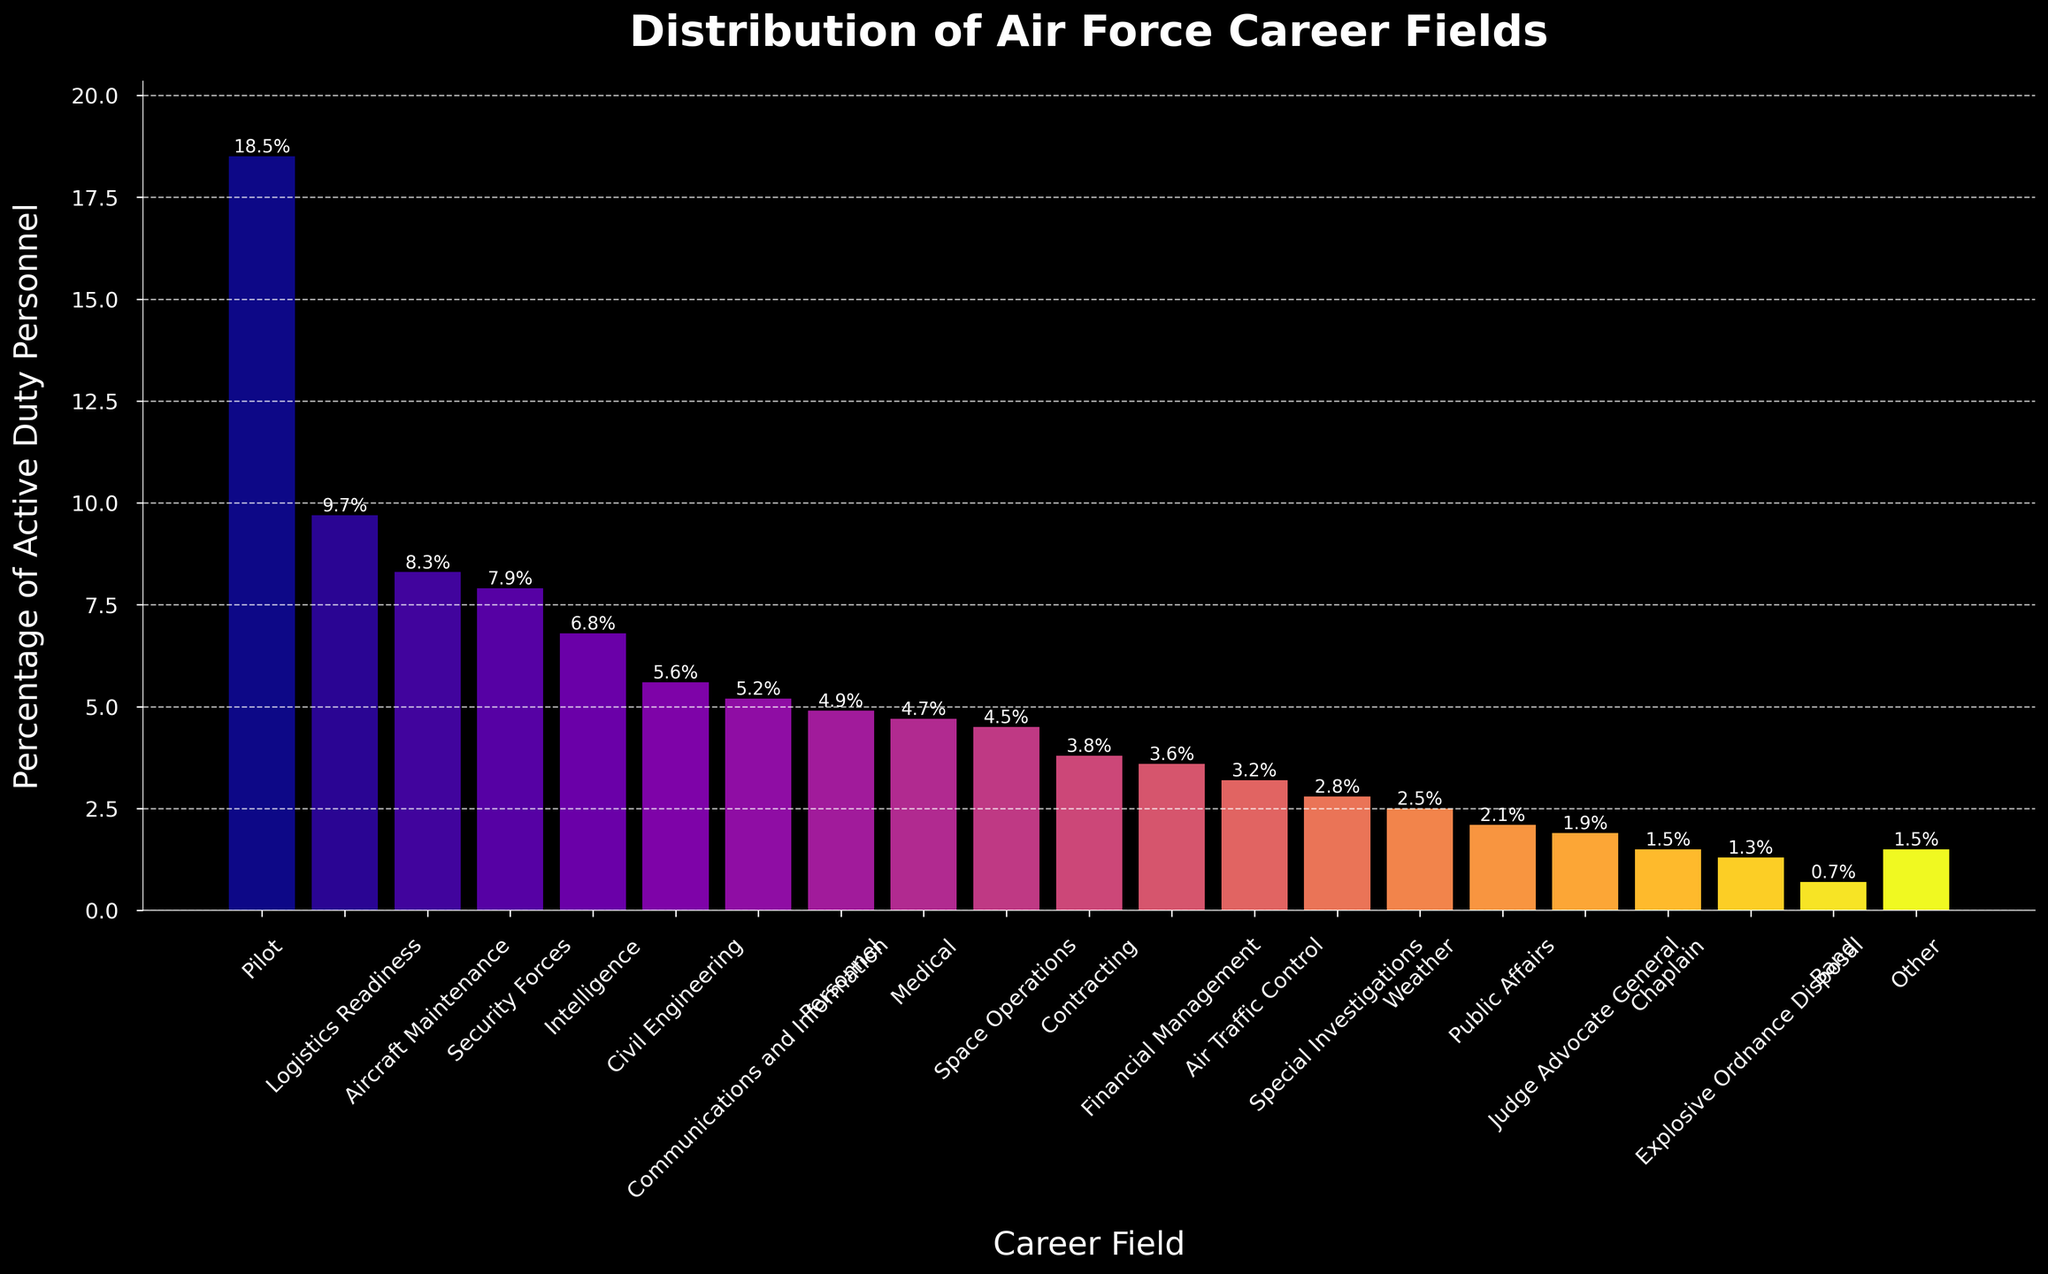What is the percentage of active duty personnel in the Pilot career field? The bar representing the Pilot career field shows a value of 18.5%.
Answer: 18.5% Which career field has a higher percentage, Security Forces or Intelligence? The bar for Security Forces shows 7.9%, while the bar for Intelligence shows 6.8%. Therefore, Security Forces has a higher percentage.
Answer: Security Forces What are the three career fields with the lowest percentages? The bars representing Band (0.7%), Explosive Ordnance Disposal (1.3%), and Chaplain (1.5%) show the lowest percentages.
Answer: Band, Explosive Ordnance Disposal, Chaplain How much greater is the percentage of active duty personnel in Logistics Readiness compared to Civil Engineering? Logistics Readiness is at 9.7% and Civil Engineering is at 5.6%. The difference is 9.7% - 5.6% = 4.1%.
Answer: 4.1% Which career field has the median percentage value, and what is this value? First, list the percentages in ascending order, then find the middle value(s): [0.7, 1.3, 1.5, 1.5, 1.9, 2.1, 2.5, 2.8, 3.2, 3.6, 3.8, 4.5, 4.7, 4.9, 5.2, 5.6, 6.8, 7.9, 8.3, 9.7, 18.5]. The median value is the 11th value, which is 3.8% (Contracting).
Answer: Contracting, 3.8% What is the total percentage of active duty personnel in the top five career fields? Summing the percentages of the top five career fields: Pilot (18.5%) + Logistics Readiness (9.7%) + Aircraft Maintenance (8.3%) + Security Forces (7.9%) + Intelligence (6.8%) = 51.2%.
Answer: 51.2% Compare the percentages of Air Traffic Control and Explosive Ordnance Disposal. Which one is higher, and by how much? The Air Traffic Control field shows 3.2%, and Explosive Ordnance Disposal shows 1.3%. The difference is 3.2% - 1.3% = 1.9%. Air Traffic Control is higher by 1.9%.
Answer: Air Traffic Control, 1.9% What is the combined percentage of Contracting and Financial Management? Adding the percentages of Contracting (3.8%) and Financial Management (3.6%): 3.8% + 3.6% = 7.4%.
Answer: 7.4% How much lower is the percentage of active duty personnel in the Band compared to Medical? The Medical career field shows 4.7%, and the Band shows 0.7%. The difference is 4.7% - 0.7% = 4.0%.
Answer: 4.0% Which career field's bar has the highest height in the plot, and what does it represent? The bar with the highest height represents the Pilot career field with a percentage of active duty personnel at 18.5%, making it the highest in the plot.
Answer: Pilot, 18.5% 